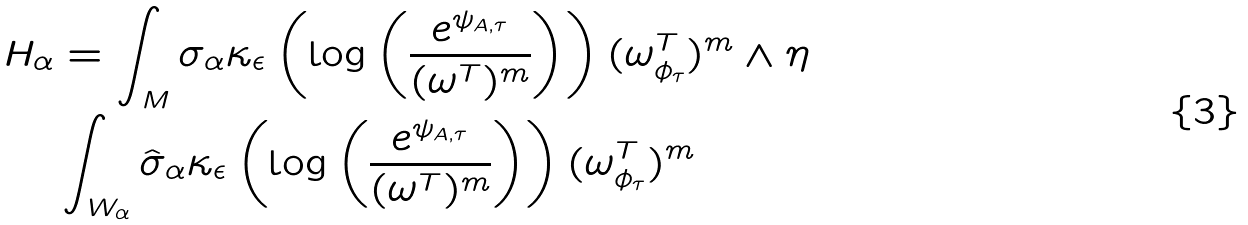<formula> <loc_0><loc_0><loc_500><loc_500>H _ { \alpha } & = \int _ { M } \sigma _ { \alpha } \kappa _ { \epsilon } \left ( \log \left ( \frac { e ^ { \psi _ { A , \tau } } } { ( \omega ^ { T } ) ^ { m } } \right ) \right ) ( \omega ^ { T } _ { \phi _ { \tau } } ) ^ { m } \wedge \eta \\ & \int _ { W _ { \alpha } } \hat { \sigma } _ { \alpha } \kappa _ { \epsilon } \left ( \log \left ( \frac { e ^ { \psi _ { A , \tau } } } { ( \omega ^ { T } ) ^ { m } } \right ) \right ) ( \omega ^ { T } _ { \phi _ { \tau } } ) ^ { m }</formula> 